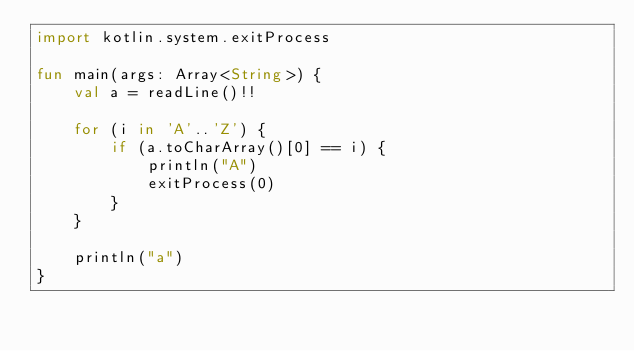Convert code to text. <code><loc_0><loc_0><loc_500><loc_500><_Kotlin_>import kotlin.system.exitProcess

fun main(args: Array<String>) {
    val a = readLine()!!

    for (i in 'A'..'Z') {
        if (a.toCharArray()[0] == i) {
            println("A")
            exitProcess(0)
        }
    }

    println("a")
}</code> 